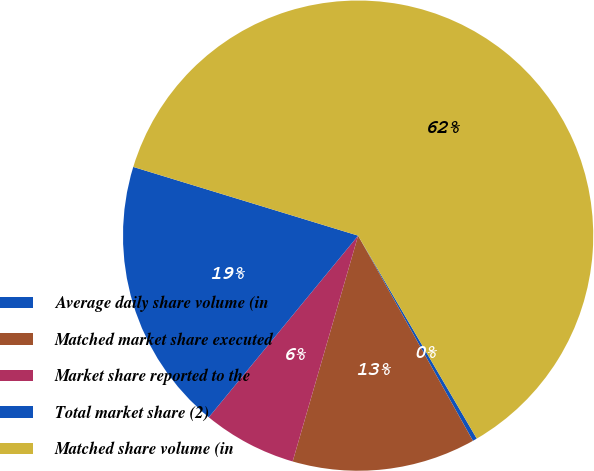<chart> <loc_0><loc_0><loc_500><loc_500><pie_chart><fcel>Average daily share volume (in<fcel>Matched market share executed<fcel>Market share reported to the<fcel>Total market share (2)<fcel>Matched share volume (in<nl><fcel>0.3%<fcel>12.61%<fcel>6.46%<fcel>18.77%<fcel>61.86%<nl></chart> 